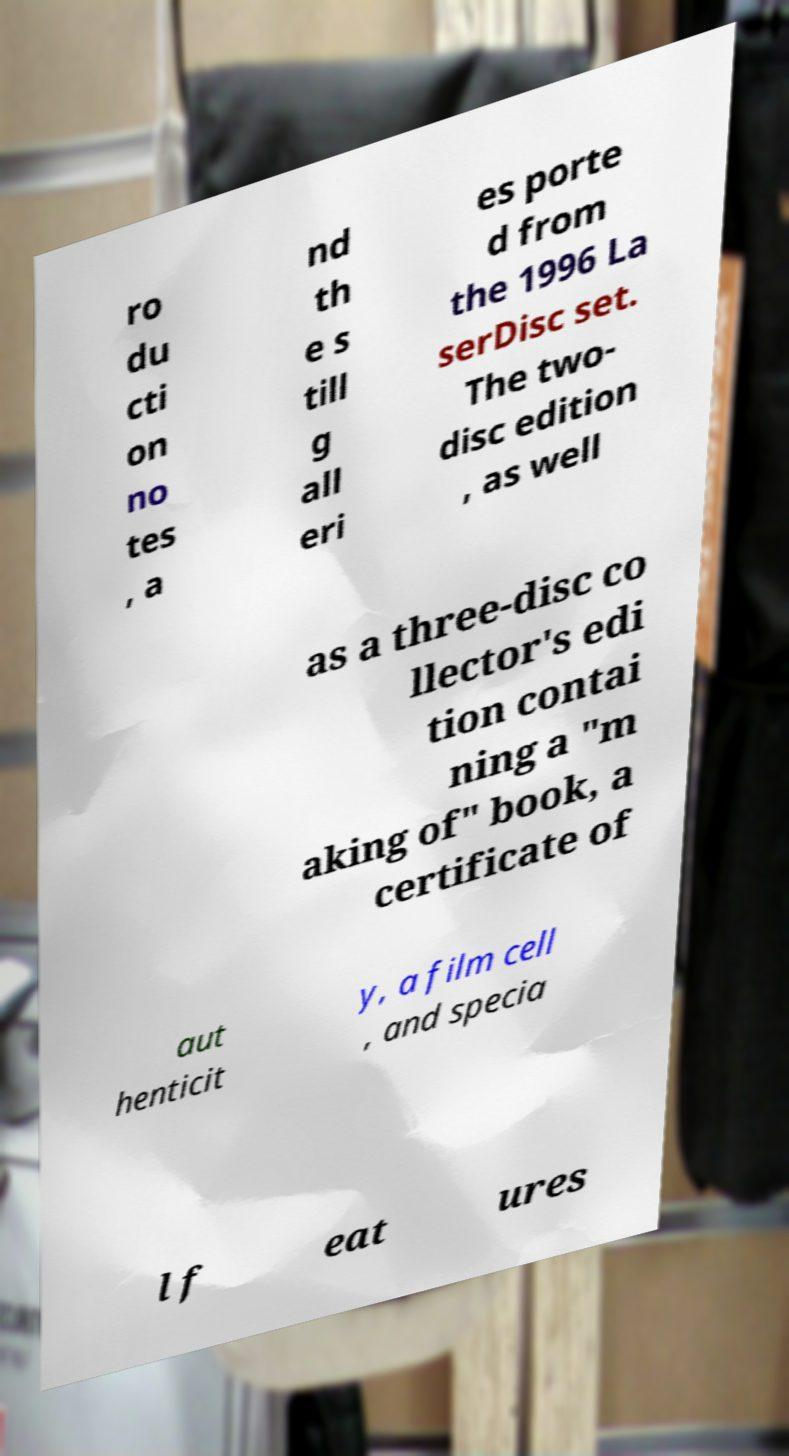For documentation purposes, I need the text within this image transcribed. Could you provide that? ro du cti on no tes , a nd th e s till g all eri es porte d from the 1996 La serDisc set. The two- disc edition , as well as a three-disc co llector's edi tion contai ning a "m aking of" book, a certificate of aut henticit y, a film cell , and specia l f eat ures 